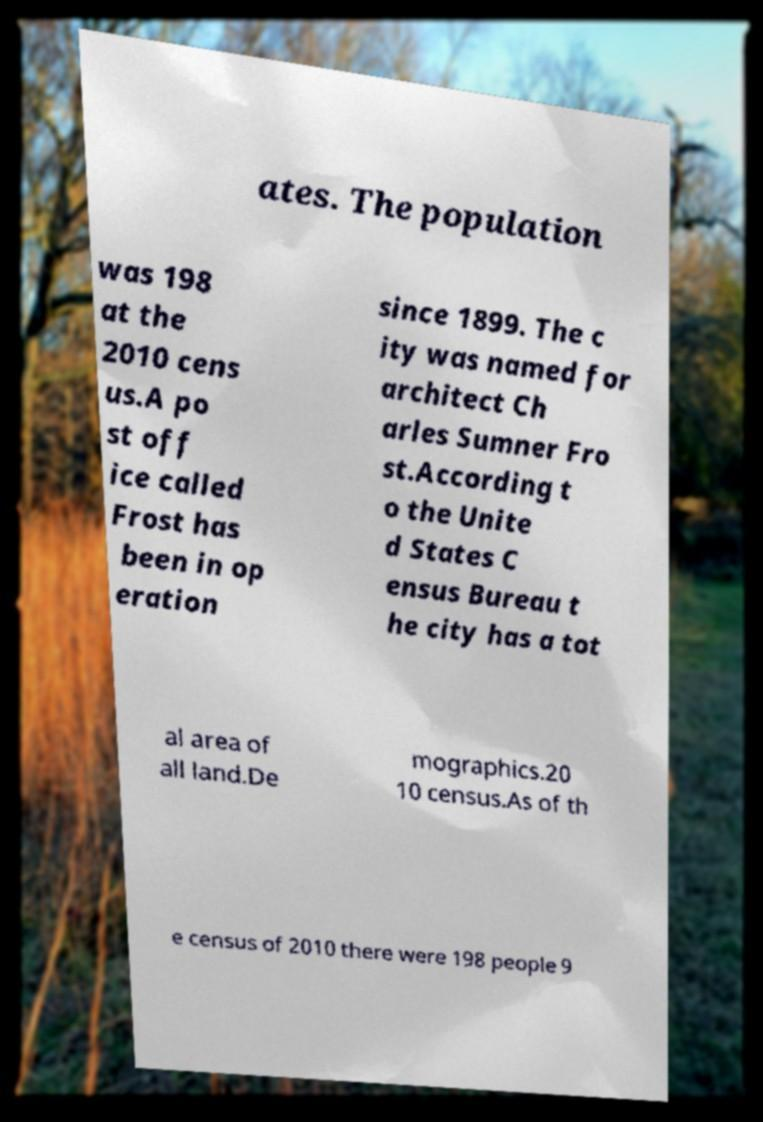I need the written content from this picture converted into text. Can you do that? ates. The population was 198 at the 2010 cens us.A po st off ice called Frost has been in op eration since 1899. The c ity was named for architect Ch arles Sumner Fro st.According t o the Unite d States C ensus Bureau t he city has a tot al area of all land.De mographics.20 10 census.As of th e census of 2010 there were 198 people 9 